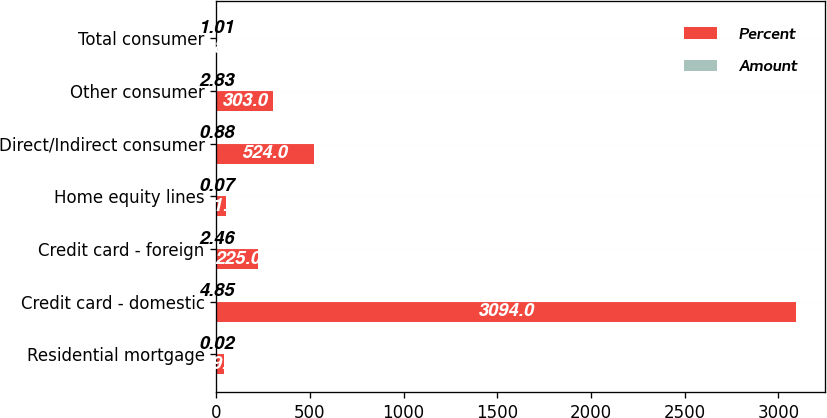Convert chart. <chart><loc_0><loc_0><loc_500><loc_500><stacked_bar_chart><ecel><fcel>Residential mortgage<fcel>Credit card - domestic<fcel>Credit card - foreign<fcel>Home equity lines<fcel>Direct/Indirect consumer<fcel>Other consumer<fcel>Total consumer<nl><fcel>Percent<fcel>39<fcel>3094<fcel>225<fcel>51<fcel>524<fcel>303<fcel>4.85<nl><fcel>Amount<fcel>0.02<fcel>4.85<fcel>2.46<fcel>0.07<fcel>0.88<fcel>2.83<fcel>1.01<nl></chart> 